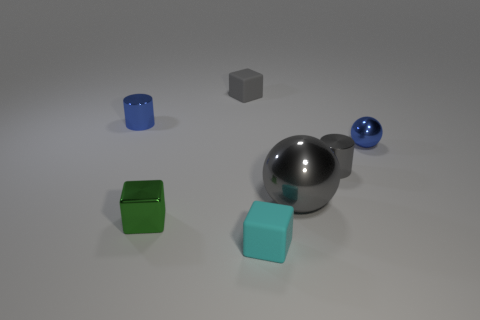Subtract all tiny rubber blocks. How many blocks are left? 1 Subtract 2 cubes. How many cubes are left? 1 Add 3 large spheres. How many objects exist? 10 Subtract all gray blocks. How many blocks are left? 2 Add 3 large gray shiny things. How many large gray shiny things are left? 4 Add 1 tiny gray metal cylinders. How many tiny gray metal cylinders exist? 2 Subtract 0 brown blocks. How many objects are left? 7 Subtract all cylinders. How many objects are left? 5 Subtract all red blocks. Subtract all blue balls. How many blocks are left? 3 Subtract all gray cubes. How many brown cylinders are left? 0 